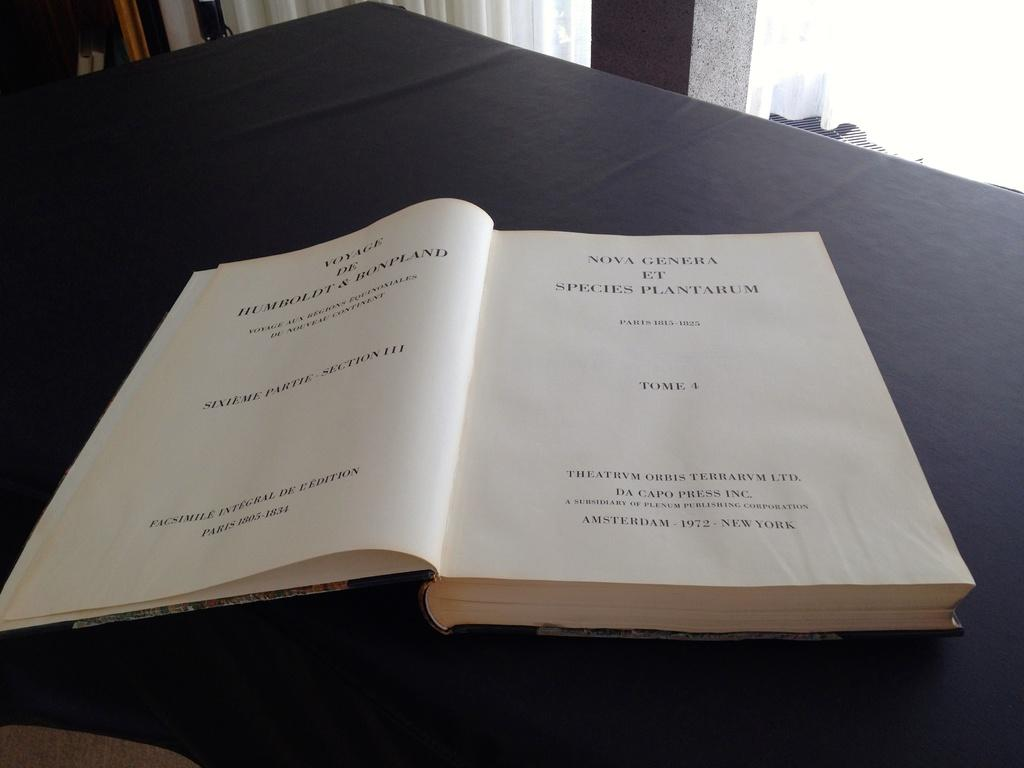<image>
Summarize the visual content of the image. A book titled 'Nova Genera et Species Plantarium'. 